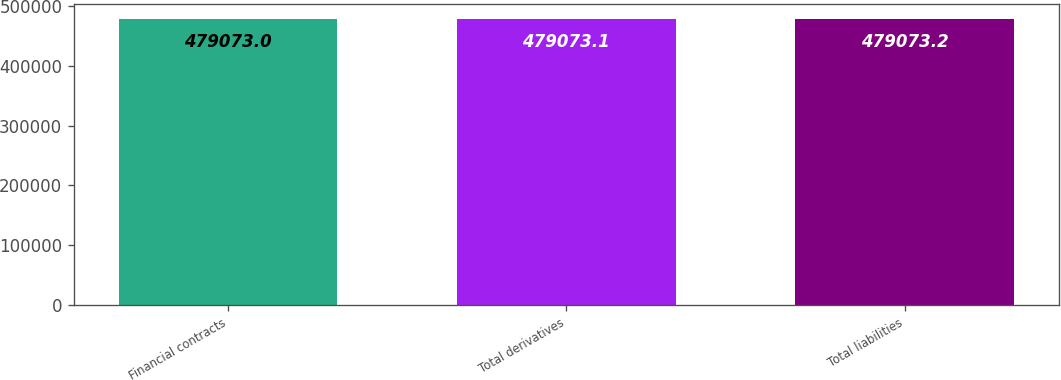<chart> <loc_0><loc_0><loc_500><loc_500><bar_chart><fcel>Financial contracts<fcel>Total derivatives<fcel>Total liabilities<nl><fcel>479073<fcel>479073<fcel>479073<nl></chart> 